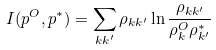<formula> <loc_0><loc_0><loc_500><loc_500>I ( p ^ { O } , p ^ { * } ) = \sum _ { k k ^ { \prime } } \rho _ { k k ^ { \prime } } \ln \frac { \rho _ { k k ^ { \prime } } } { \rho ^ { O } _ { k } \rho ^ { * } _ { k ^ { \prime } } }</formula> 